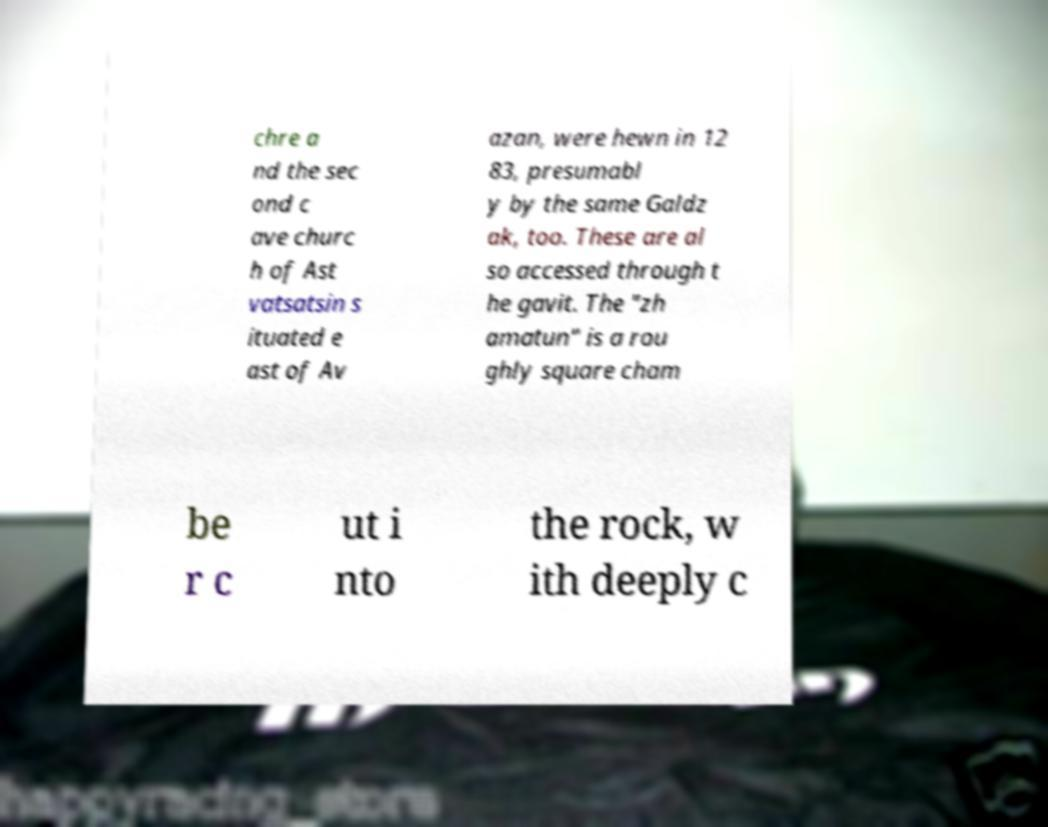Please read and relay the text visible in this image. What does it say? chre a nd the sec ond c ave churc h of Ast vatsatsin s ituated e ast of Av azan, were hewn in 12 83, presumabl y by the same Galdz ak, too. These are al so accessed through t he gavit. The "zh amatun" is a rou ghly square cham be r c ut i nto the rock, w ith deeply c 